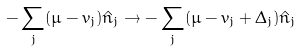Convert formula to latex. <formula><loc_0><loc_0><loc_500><loc_500>- \sum _ { j } ( \mu - v _ { j } ) \hat { n } _ { j } \rightarrow - \sum _ { j } ( \mu - v _ { j } + \Delta _ { j } ) \hat { n } _ { j }</formula> 